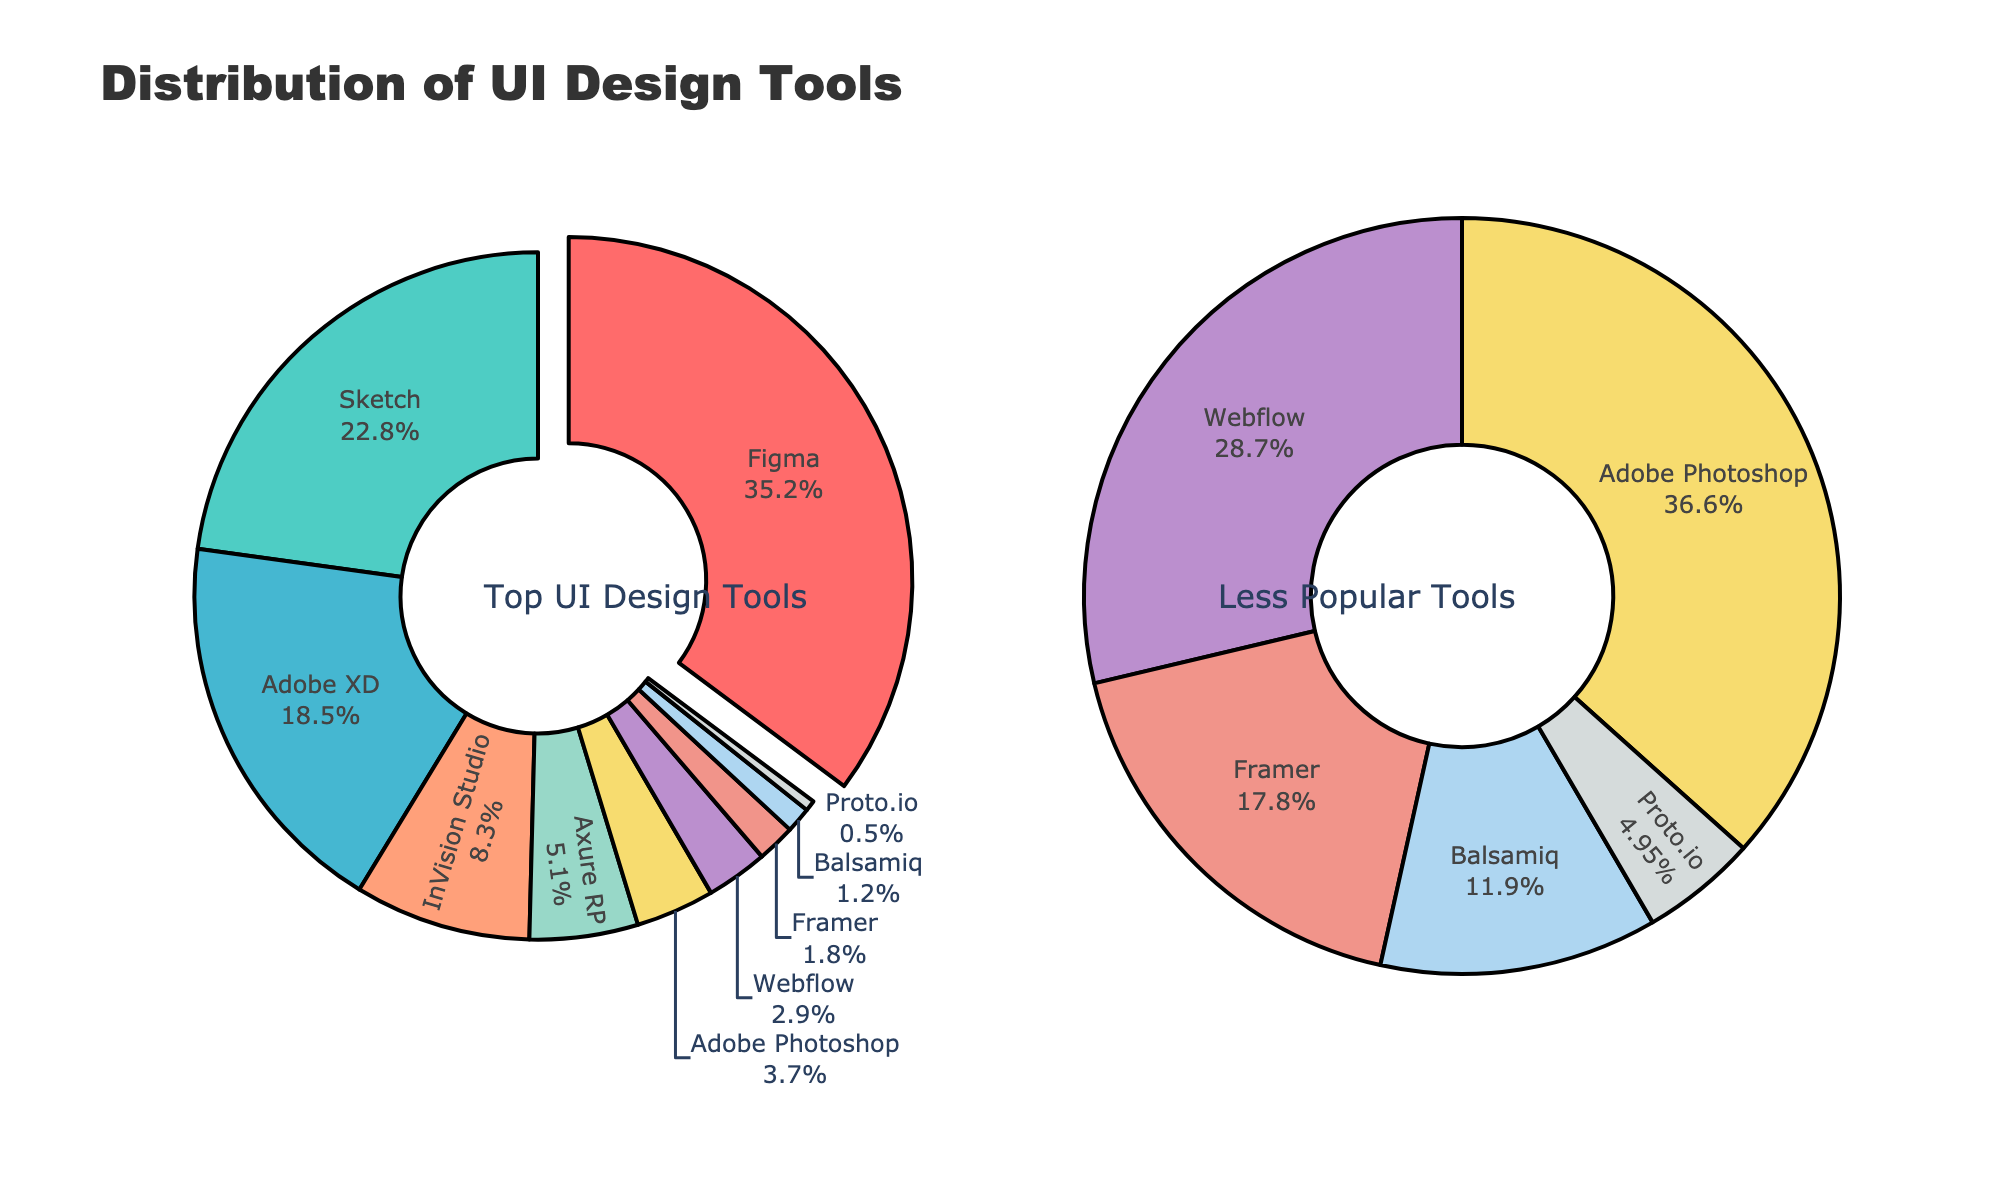What percentage of professional designers use Adobe XD compared to Sketch? First, identify the percentage for both Adobe XD and Sketch from the pie chart. Adobe XD has 18.5%, and Sketch has 22.8%. Then compare these two values.
Answer: Adobe XD (18.5%) is less than Sketch (22.8%) How many tools have a usage percentage less than 5%? Observe the smaller pie chart which displays tools with less than 5% usage. Count the tools shown: Axure RP, Adobe Photoshop, Webflow, Framer, Balsamiq, and Proto.io. This totals 6 tools.
Answer: 6 tools Which tool holds the largest share in the main pie chart? Look at the labels and percentages in the main pie chart to find the tool with the highest percentage value. Figma has the highest percentage of 35.2%.
Answer: Figma What is the total percentage of usage for Adobe XD and InVision Studio combined? Find the percentages for Adobe XD (18.5%) and InVision Studio (8.3%) in the pie chart. Sum these values: 18.5% + 8.3% = 26.8%.
Answer: 26.8% Which has a higher usage percentage, Axure RP or Adobe Photoshop? Identify the percentages for Axure RP (5.1%) and Adobe Photoshop (3.7%). Compare these values. Axure RP is greater than Adobe Photoshop.
Answer: Axure RP What is the combined share of the smallest three tools? Identify the three smallest percentages: Proto.io (0.5%), Balsamiq (1.2%), and Framer (1.8%). Sum these values: 0.5% + 1.2% + 1.8% = 3.5%.
Answer: 3.5% How does the usage of Webflow compare to the combined usage of Balsamiq and Proto.io? Identify the percentages for Webflow (2.9%), Balsamiq (1.2%), and Proto.io (0.5%). Sum the percentages for Balsamiq and Proto.io: 1.2% + 0.5% = 1.7%. Compare 2.9% (Webflow) to 1.7%: Webflow is larger.
Answer: Webflow is larger Is the total usage percentage of Sketch and Adobe XD greater than Figma alone? Find the percentages for Sketch (22.8%), Adobe XD (18.5%), and Figma (35.2%). Sum the percentages of Sketch and Adobe XD: 22.8% + 18.5% = 41.3%, which is greater than Figma's 35.2%.
Answer: Yes What is the combined usage percentage of all tools in the smaller pie chart? Identify the percentage for each tool in the smaller pie chart: Axure RP (5.1%), Adobe Photoshop (3.7%), Webflow (2.9%), Framer (1.8%), Balsamiq (1.2%), and Proto.io (0.5%). Sum these values: 5.1% + 3.7% + 2.9% + 1.8% + 1.2% + 0.5% = 15.2%.
Answer: 15.2% What is the most used tool among those with a usage percentage less than 5%? Examine the smaller pie chart and identify the tool with the highest percentage. Axure RP has the highest percentage (5.1%) among the tools in the smaller pie chart.
Answer: Axure RP 